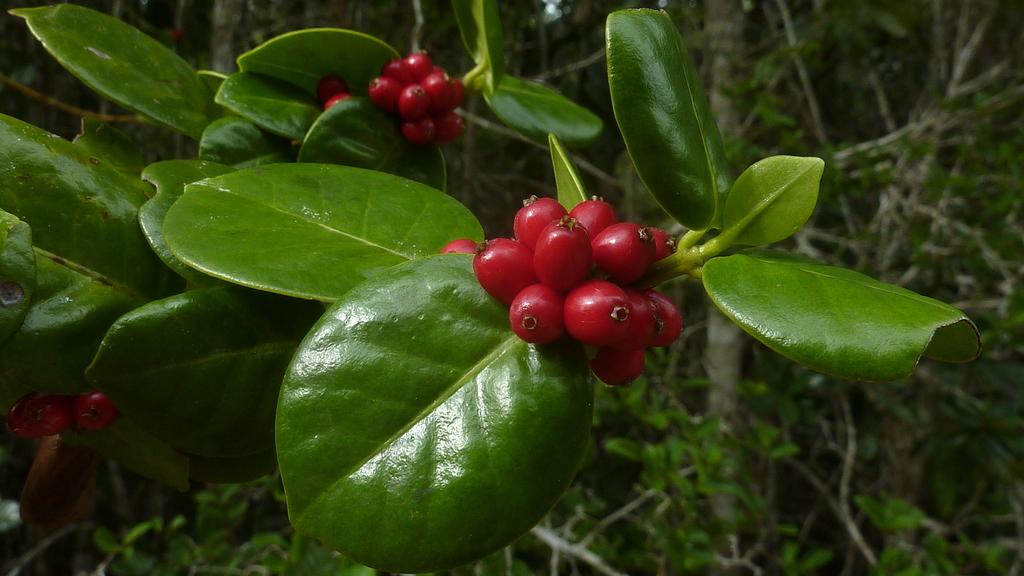What types of living organisms can be seen in the image? There are many plants in the image. What else can be seen in the image besides plants? There are some fruits in the image. What is the color of the fruits in the image? The fruits are red in color. What type of battle is depicted in the image? There is no battle present in the image; it features many plants and some red fruits. How does the process of copying the plants occur in the image? There is no process of copying the plants depicted in the image. 